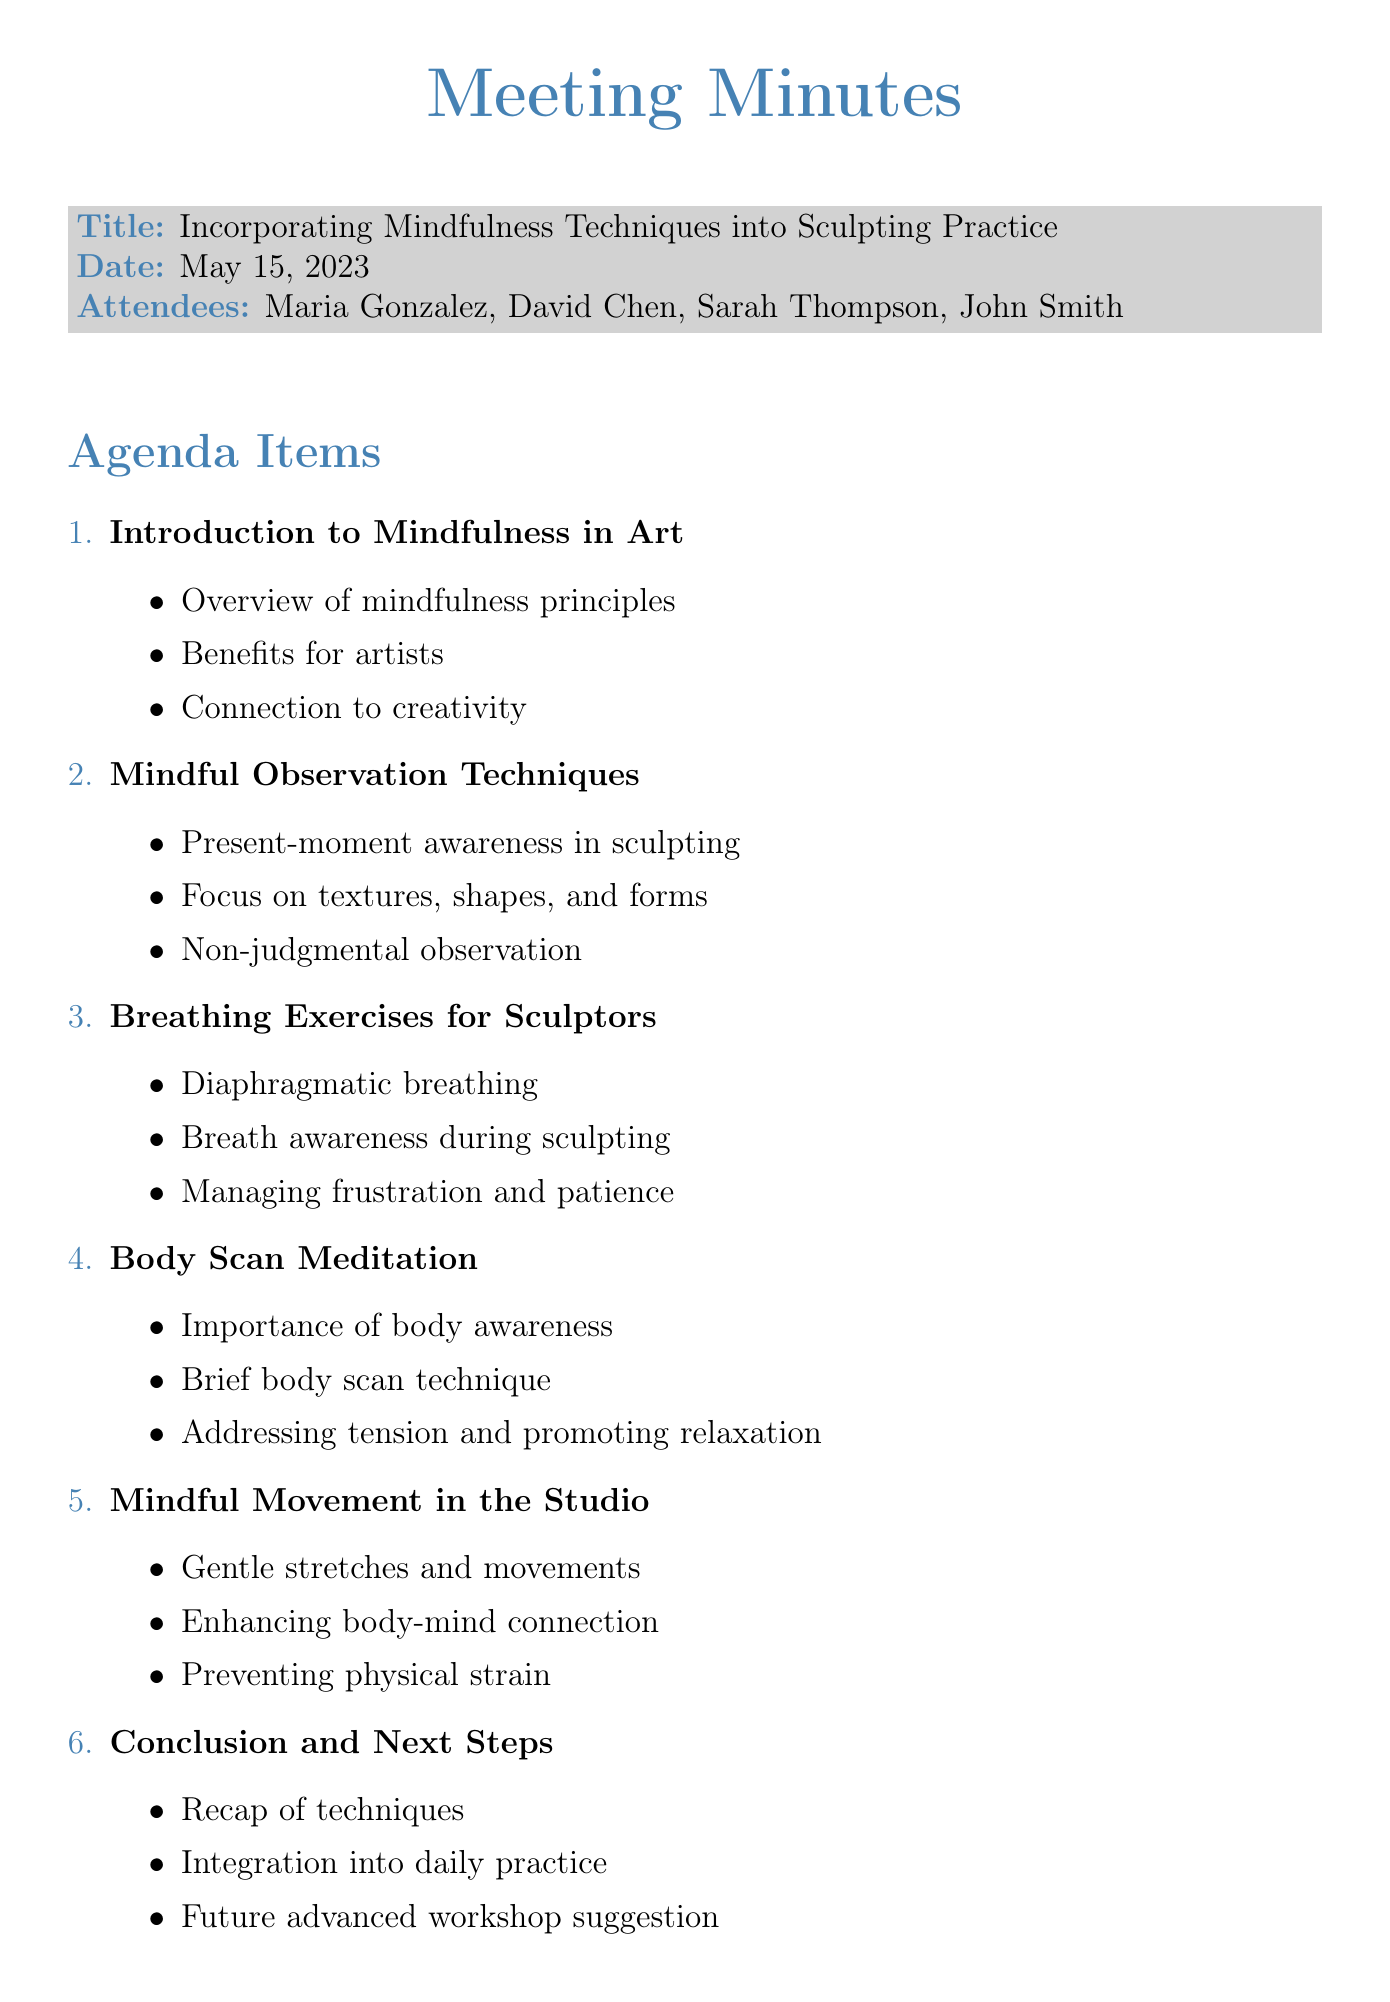What was the date of the meeting? The date of the meeting is explicitly stated in the document.
Answer: May 15, 2023 Who led the meeting? The meeting title includes the instructor's name, indicating she led the discussion.
Answer: Maria Gonzalez What is one of the benefits of mindfulness mentioned? The key points outline specific benefits related to artists.
Answer: Benefits of mindfulness for artists Which technique is suggested for managing frustration? The key points specify breathing exercises as a method to manage frustration.
Answer: Breath awareness during sculpting How many action items were there? The action items list the specific tasks agreed upon during the meeting.
Answer: Four 